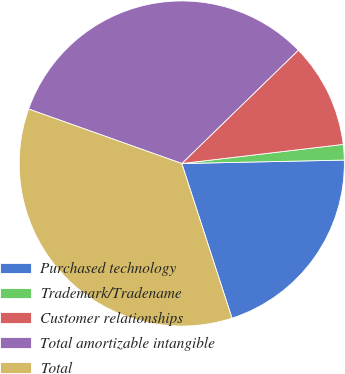Convert chart to OTSL. <chart><loc_0><loc_0><loc_500><loc_500><pie_chart><fcel>Purchased technology<fcel>Trademark/Tradename<fcel>Customer relationships<fcel>Total amortizable intangible<fcel>Total<nl><fcel>20.34%<fcel>1.54%<fcel>10.4%<fcel>32.28%<fcel>35.43%<nl></chart> 